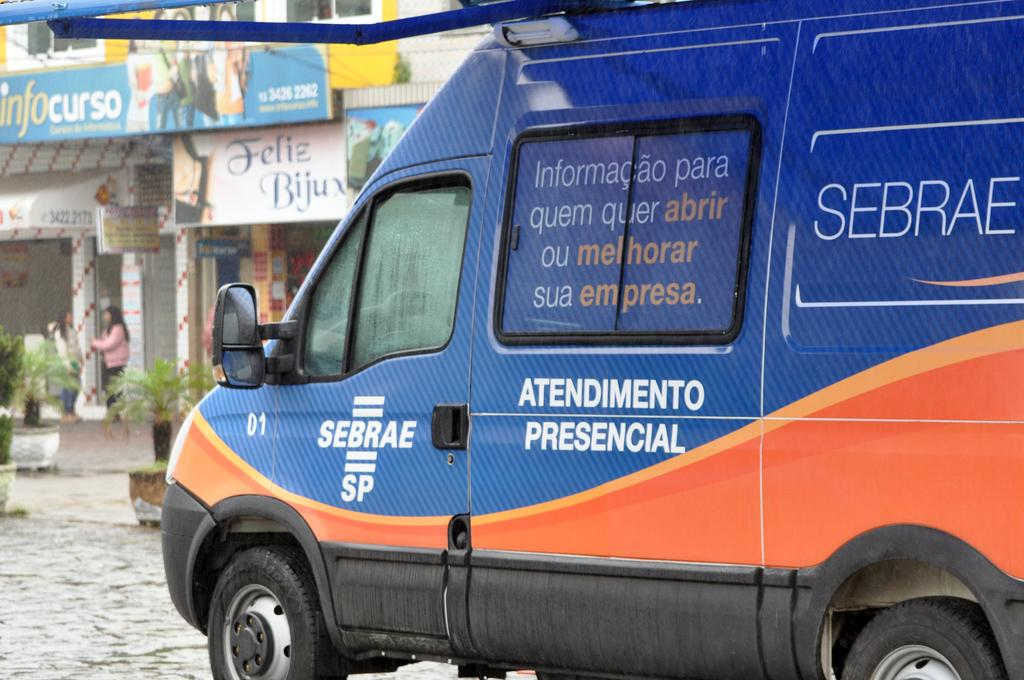<image>
Present a compact description of the photo's key features. A blue and orange foreign emergency services vehicle Atendimento Presencial 